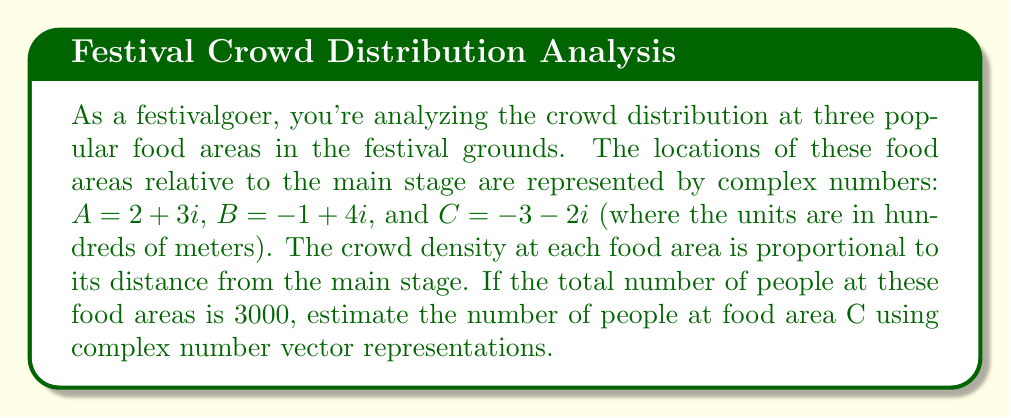What is the answer to this math problem? Let's approach this step-by-step:

1) First, we need to calculate the distances of each food area from the main stage (origin). We can do this by finding the modulus of each complex number.

   For $A: |A| = \sqrt{2^2 + 3^2} = \sqrt{13}$
   For $B: |B| = \sqrt{(-1)^2 + 4^2} = \sqrt{17}$
   For $C: |C| = \sqrt{(-3)^2 + (-2)^2} = \sqrt{13}$

2) The crowd density is proportional to the distance, so we can use these distances as weights for distribution.

3) Let's call the total weight $W$:

   $W = \sqrt{13} + \sqrt{17} + \sqrt{13} = 2\sqrt{13} + \sqrt{17}$

4) Now, the fraction of people at C would be:

   $\frac{\sqrt{13}}{2\sqrt{13} + \sqrt{17}}$

5) To get the number of people at C, we multiply this fraction by the total number of people:

   $N_C = 3000 \cdot \frac{\sqrt{13}}{2\sqrt{13} + \sqrt{17}}$

6) Simplifying:

   $N_C = \frac{3000\sqrt{13}}{2\sqrt{13} + \sqrt{17}}$

7) Using a calculator (or computer) to evaluate this:

   $N_C \approx 1087.48$

8) Rounding to the nearest whole number:

   $N_C \approx 1087$ people
Answer: Approximately 1087 people are at food area C. 